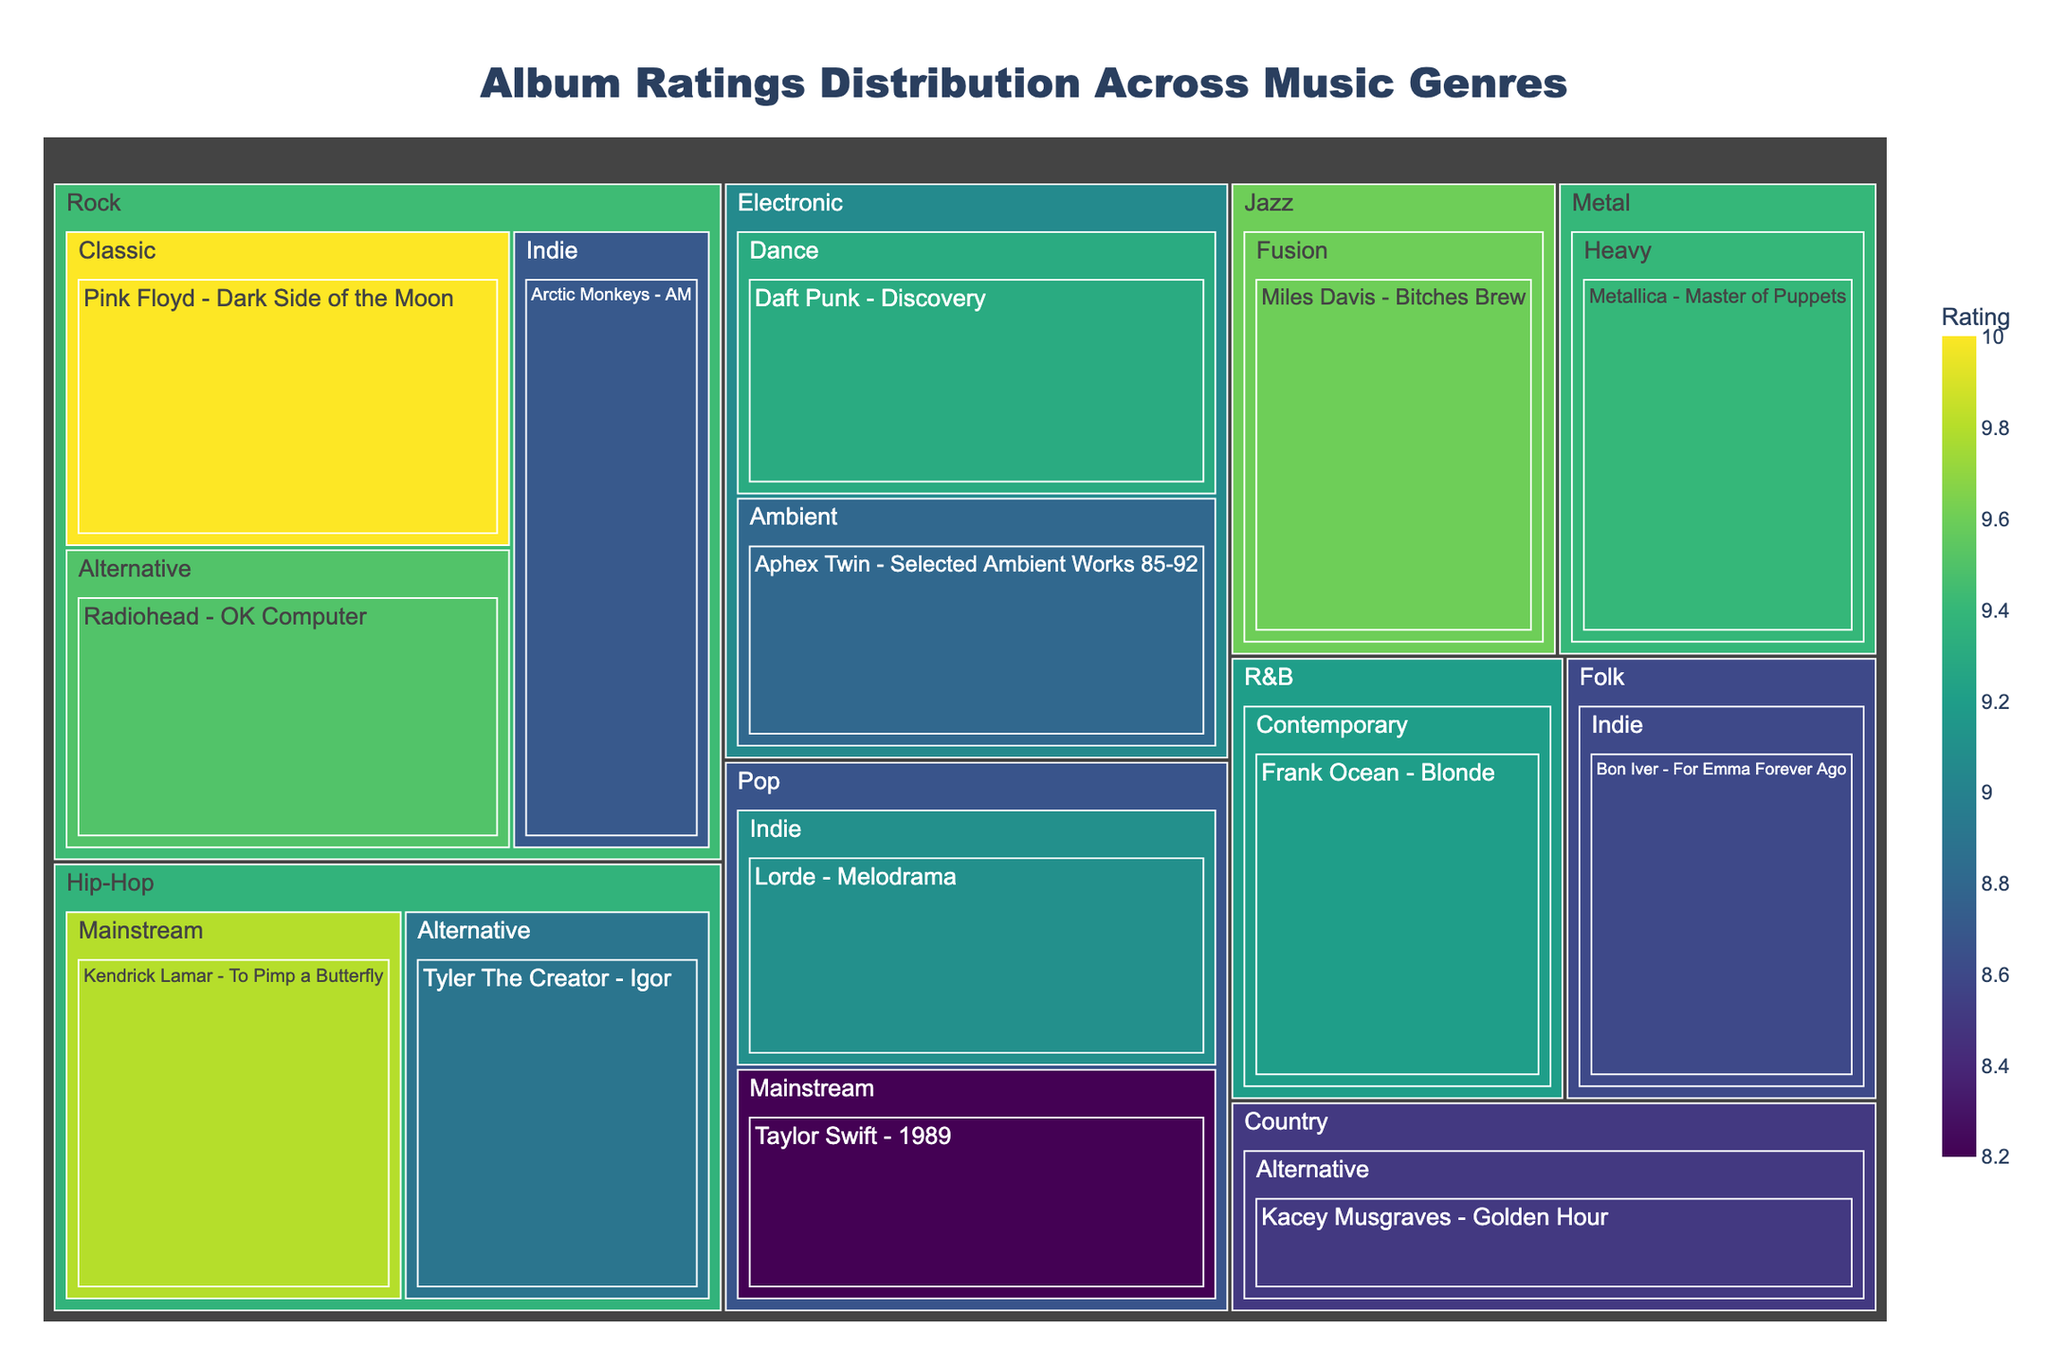What is the rating of the album "Radiohead - OK Computer"? Locate the album "Radiohead - OK Computer" under the "Rock" genre in the "Alternative" subgenre section and check its associated rating.
Answer: 9.5 Which genre has the album with the highest rating? Identify the album with the highest rating in the Treemap. "Pink Floyd - Dark Side of the Moon" under the "Classic" Rock subgenre has a rating of 10. The genre is "Rock".
Answer: Rock How many subgenres are under the "Pop" genre? Count the subgenres listed under the "Pop" genre section in the Treemap. The "Pop" genre has two subgenres: "Mainstream" and "Indie".
Answer: 2 What is the average rating of the albums in the "Electronic" genre? Locate the "Electronic" genre and identify the ratings of its albums. There are two albums: "Daft Punk - Discovery" with 9.3 and "Aphex Twin - Selected Ambient Works 85-92" with 8.8. Calculate the average: (9.3 + 8.8) / 2 = 9.05.
Answer: 9.05 Which subgenre in "Hip-Hop" has a higher rating and by how much? Compare the ratings of the two subgenres under "Hip-Hop": Mainstream ("Kendrick Lamar - To Pimp a Butterfly" with 9.8) and Alternative ("Tyler The Creator - Igor" with 8.9). Calculate the difference: 9.8 - 8.9 = 0.9.
Answer: Mainstream by 0.9 Which album has the lowest rating and what is its value? Identify the album with the smallest color area and the lowest numerical value in the Treemap. "Taylor Swift - 1989" under the Mainstream Pop subgenre has the lowest rating of 8.2.
Answer: Taylor Swift - 1989, 8.2 What is the total number of albums displayed in the Treemap? Count all the individual album entries in each genre and subgenre of the Treemap. There are 14 albums in total.
Answer: 14 Which genre has the most diverse range of subgenres? Check the number of subgenres listed under each genre in the Treemap. The "Rock" genre has three subgenres: Alternative, Classic, and Indie, which is the most diverse range.
Answer: Rock Is the average rating of albums in the "Rock" genre higher than that in the "Pop" genre? Calculate the average rating for "Rock" albums: (9.5 + 10 + 8.7) / 3 = 9.4. Calculate the average rating for "Pop" albums: (8.2 + 9.1) / 2 = 8.65. Compare the averages: 9.4 is greater than 8.65.
Answer: Yes Which genre has the highest-rated "Indie" subgenre album? Look for the highest rating in the "Indie" subgenre albums across genres. "Bon Iver - For Emma Forever Ago" in "Folk" has 8.6, "Arctic Monkeys - AM" in "Rock" has 8.7, and "Lorde - Melodrama" in "Pop" has 9.1. The highest-rated "Indie" album is in "Pop".
Answer: Pop 